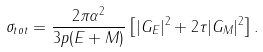Convert formula to latex. <formula><loc_0><loc_0><loc_500><loc_500>\sigma _ { t o t } = \frac { 2 \pi \alpha ^ { 2 } } { 3 p ( E + M ) } \left [ | G _ { E } | ^ { 2 } + 2 \tau | G _ { M } | ^ { 2 } \right ] .</formula> 